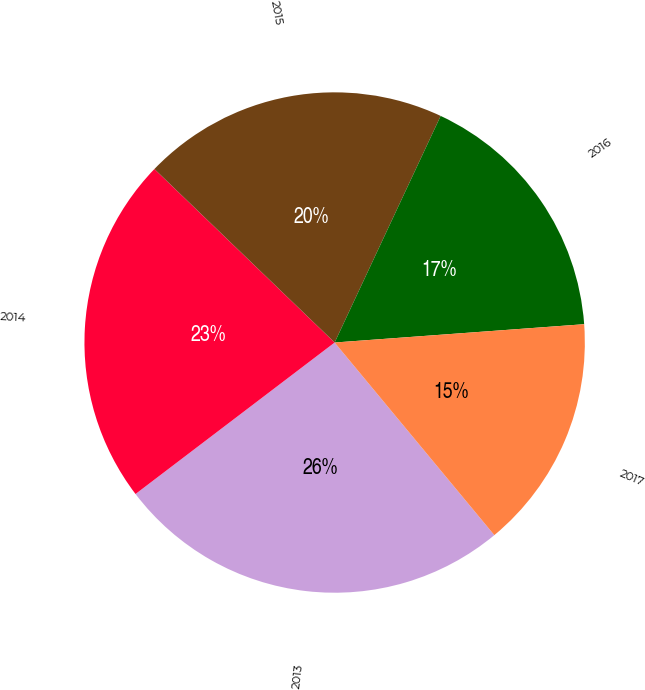Convert chart to OTSL. <chart><loc_0><loc_0><loc_500><loc_500><pie_chart><fcel>2013<fcel>2014<fcel>2015<fcel>2016<fcel>2017<nl><fcel>25.67%<fcel>22.55%<fcel>19.77%<fcel>16.87%<fcel>15.15%<nl></chart> 